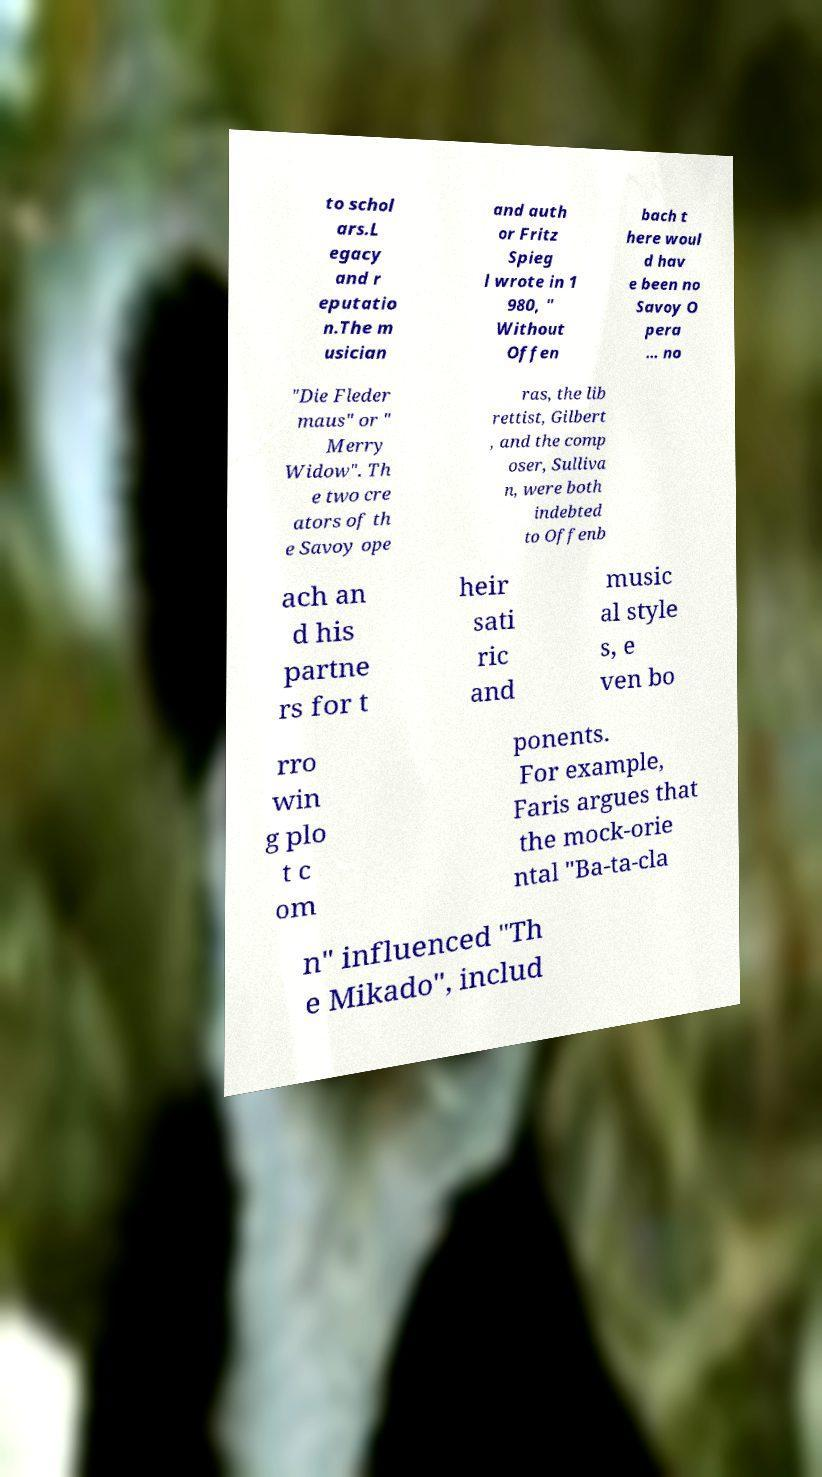Please read and relay the text visible in this image. What does it say? to schol ars.L egacy and r eputatio n.The m usician and auth or Fritz Spieg l wrote in 1 980, " Without Offen bach t here woul d hav e been no Savoy O pera … no "Die Fleder maus" or " Merry Widow". Th e two cre ators of th e Savoy ope ras, the lib rettist, Gilbert , and the comp oser, Sulliva n, were both indebted to Offenb ach an d his partne rs for t heir sati ric and music al style s, e ven bo rro win g plo t c om ponents. For example, Faris argues that the mock-orie ntal "Ba-ta-cla n" influenced "Th e Mikado", includ 